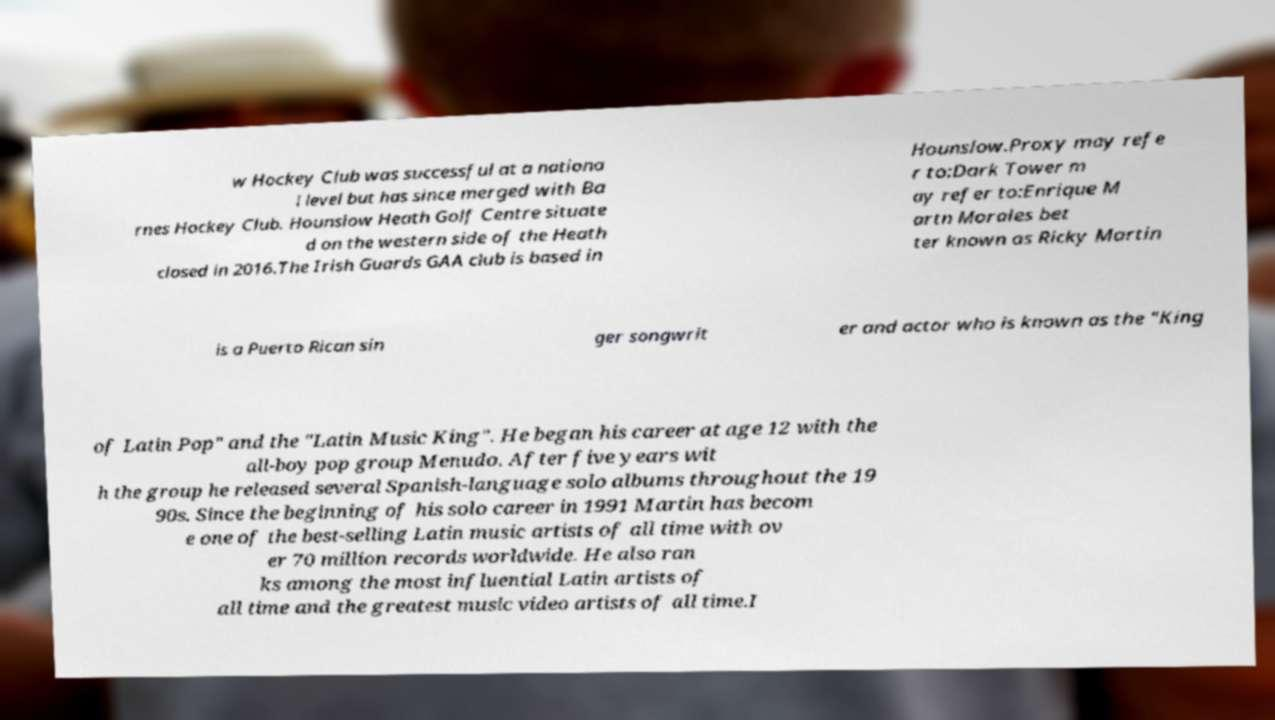For documentation purposes, I need the text within this image transcribed. Could you provide that? w Hockey Club was successful at a nationa l level but has since merged with Ba rnes Hockey Club. Hounslow Heath Golf Centre situate d on the western side of the Heath closed in 2016.The Irish Guards GAA club is based in Hounslow.Proxy may refe r to:Dark Tower m ay refer to:Enrique M artn Morales bet ter known as Ricky Martin is a Puerto Rican sin ger songwrit er and actor who is known as the "King of Latin Pop" and the "Latin Music King". He began his career at age 12 with the all-boy pop group Menudo. After five years wit h the group he released several Spanish-language solo albums throughout the 19 90s. Since the beginning of his solo career in 1991 Martin has becom e one of the best-selling Latin music artists of all time with ov er 70 million records worldwide. He also ran ks among the most influential Latin artists of all time and the greatest music video artists of all time.I 